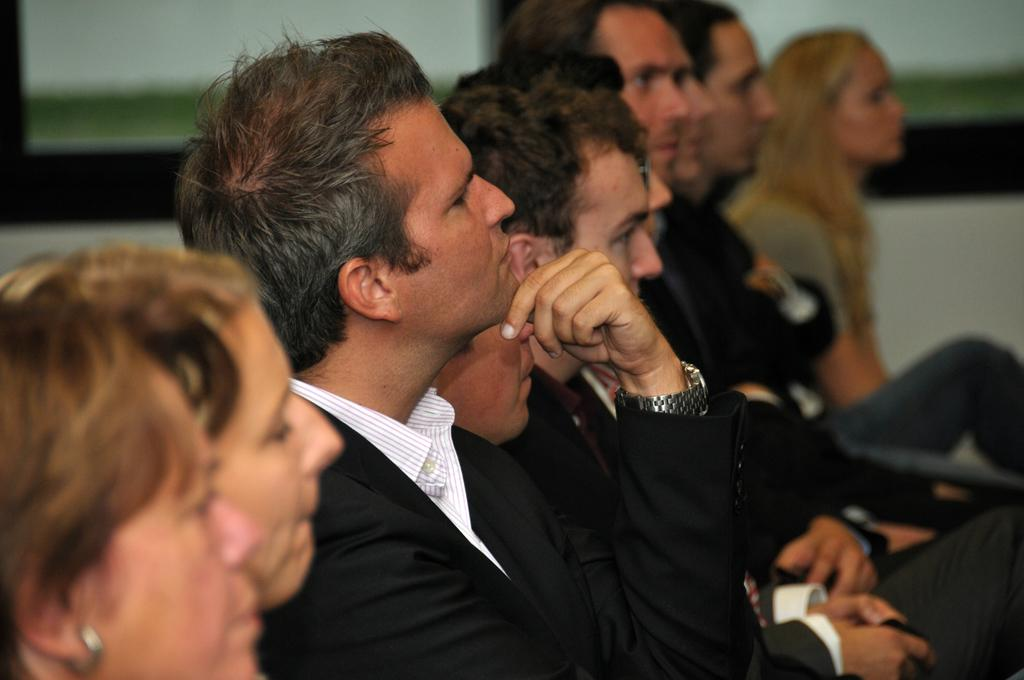What are the people in the image doing? The people in the image are sitting. Can you describe the clothing of one of the individuals? One person is wearing a black suit. What accessory is the person in the black suit wearing? The person in the black suit is wearing a silver watch. What type of horse can be seen grazing in the background of the image? There is no horse present in the image; it only features people sitting. How does the light affect the growth of the plants in the image? There are no plants visible in the image, so it is not possible to determine the effect of light on their growth. 